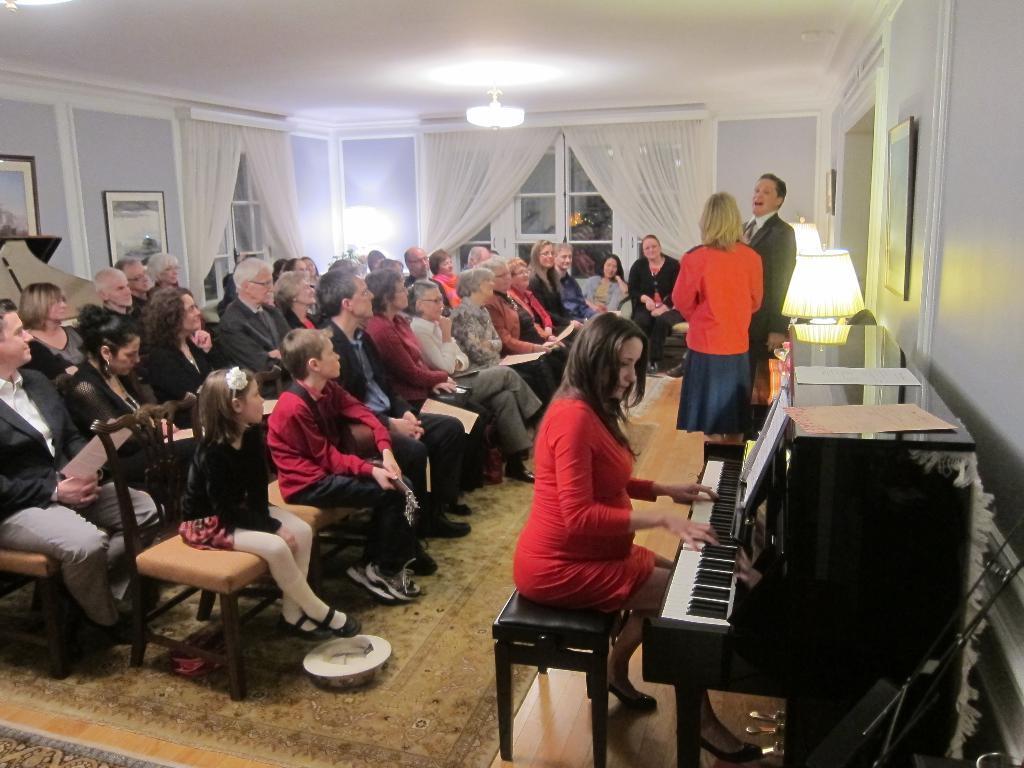Could you give a brief overview of what you see in this image? There is a group of a people. They are sitting on a chair. The remaining two persons are standing. In the front we have a red color dress women. She is playing a keyboard. We can see in the background there is a curtain,wall and photo frame. 